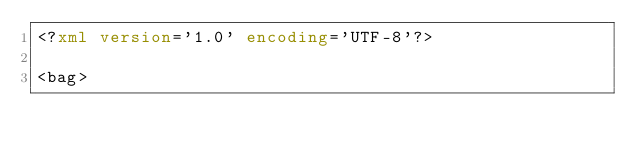Convert code to text. <code><loc_0><loc_0><loc_500><loc_500><_XML_><?xml version='1.0' encoding='UTF-8'?>

<bag></code> 